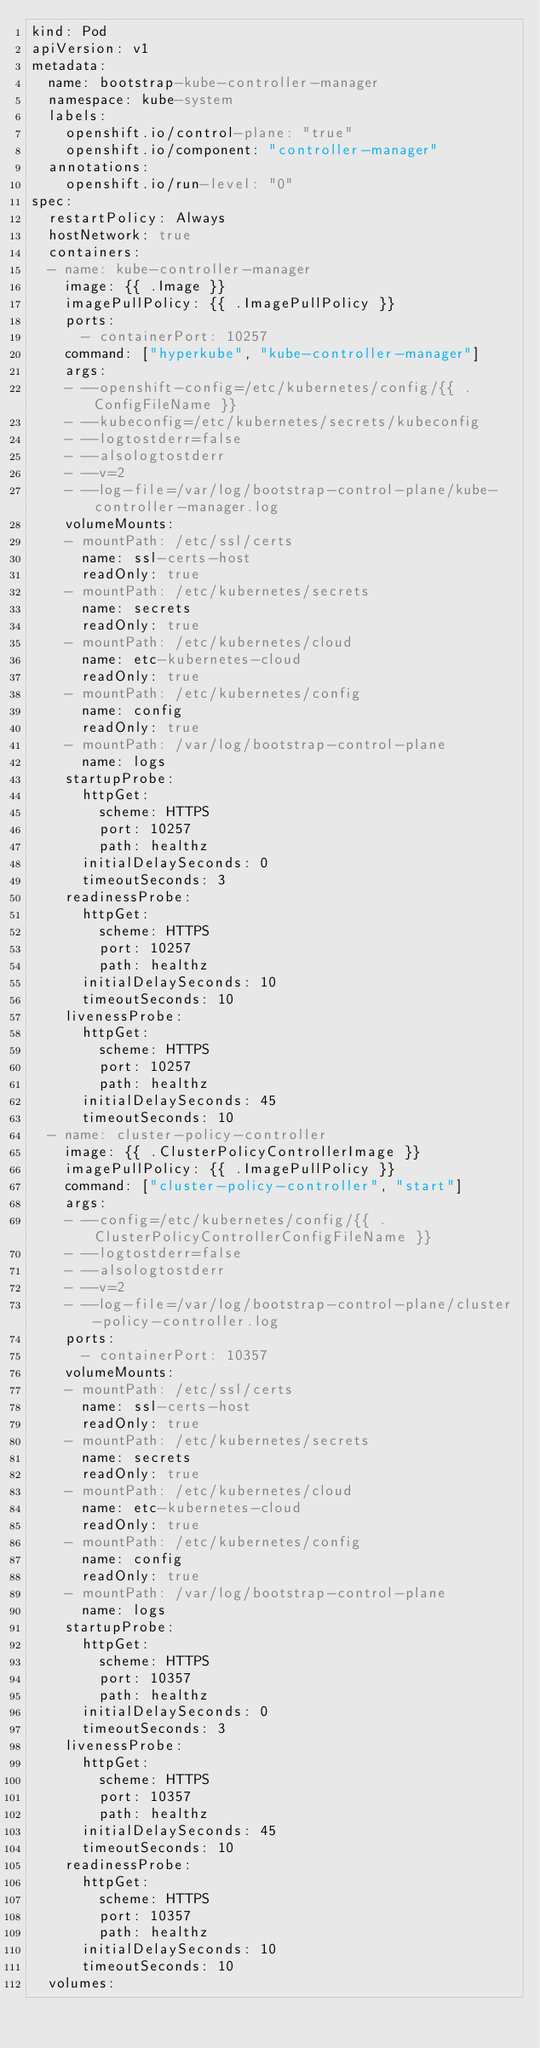Convert code to text. <code><loc_0><loc_0><loc_500><loc_500><_YAML_>kind: Pod
apiVersion: v1
metadata:
  name: bootstrap-kube-controller-manager
  namespace: kube-system
  labels:
    openshift.io/control-plane: "true"
    openshift.io/component: "controller-manager"
  annotations:
    openshift.io/run-level: "0"
spec:
  restartPolicy: Always
  hostNetwork: true
  containers:
  - name: kube-controller-manager
    image: {{ .Image }}
    imagePullPolicy: {{ .ImagePullPolicy }}
    ports:
      - containerPort: 10257
    command: ["hyperkube", "kube-controller-manager"]
    args:
    - --openshift-config=/etc/kubernetes/config/{{ .ConfigFileName }}
    - --kubeconfig=/etc/kubernetes/secrets/kubeconfig
    - --logtostderr=false
    - --alsologtostderr
    - --v=2
    - --log-file=/var/log/bootstrap-control-plane/kube-controller-manager.log
    volumeMounts:
    - mountPath: /etc/ssl/certs
      name: ssl-certs-host
      readOnly: true
    - mountPath: /etc/kubernetes/secrets
      name: secrets
      readOnly: true
    - mountPath: /etc/kubernetes/cloud
      name: etc-kubernetes-cloud
      readOnly: true
    - mountPath: /etc/kubernetes/config
      name: config
      readOnly: true
    - mountPath: /var/log/bootstrap-control-plane
      name: logs
    startupProbe:
      httpGet:
        scheme: HTTPS
        port: 10257
        path: healthz
      initialDelaySeconds: 0
      timeoutSeconds: 3
    readinessProbe:
      httpGet:
        scheme: HTTPS
        port: 10257
        path: healthz
      initialDelaySeconds: 10
      timeoutSeconds: 10
    livenessProbe:
      httpGet:
        scheme: HTTPS
        port: 10257
        path: healthz
      initialDelaySeconds: 45
      timeoutSeconds: 10
  - name: cluster-policy-controller
    image: {{ .ClusterPolicyControllerImage }}
    imagePullPolicy: {{ .ImagePullPolicy }}
    command: ["cluster-policy-controller", "start"]
    args:
    - --config=/etc/kubernetes/config/{{ .ClusterPolicyControllerConfigFileName }}
    - --logtostderr=false
    - --alsologtostderr
    - --v=2
    - --log-file=/var/log/bootstrap-control-plane/cluster-policy-controller.log
    ports:
      - containerPort: 10357
    volumeMounts:
    - mountPath: /etc/ssl/certs
      name: ssl-certs-host
      readOnly: true
    - mountPath: /etc/kubernetes/secrets
      name: secrets
      readOnly: true
    - mountPath: /etc/kubernetes/cloud
      name: etc-kubernetes-cloud
      readOnly: true
    - mountPath: /etc/kubernetes/config
      name: config
      readOnly: true
    - mountPath: /var/log/bootstrap-control-plane
      name: logs
    startupProbe:
      httpGet:
        scheme: HTTPS
        port: 10357
        path: healthz
      initialDelaySeconds: 0
      timeoutSeconds: 3
    livenessProbe:
      httpGet:
        scheme: HTTPS
        port: 10357
        path: healthz
      initialDelaySeconds: 45
      timeoutSeconds: 10
    readinessProbe:
      httpGet:
        scheme: HTTPS
        port: 10357
        path: healthz
      initialDelaySeconds: 10
      timeoutSeconds: 10
  volumes:</code> 